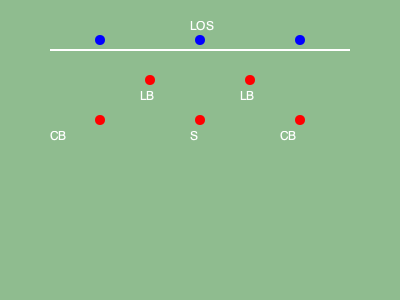Based on the defensive player positioning shown in the diagram, what type of coverage is being displayed? To identify the defensive coverage, let's analyze the positioning of the players step-by-step:

1. We can see 5 defensive players (red circles) lined up against 3 offensive players (blue circles).

2. There are two cornerbacks (CB) positioned on the outside, near the line of scrimmage (LOS).

3. Two linebackers (LB) are positioned slightly back from the LOS, forming a square-like shape with the CBs.

4. A single safety (S) is positioned deep in the middle of the field.

5. This formation with two CBs playing close to the LOS, two LBs in the middle, and a single high safety is characteristic of a Cover 3 zone defense.

6. In Cover 3, the two CBs and the deep safety are responsible for covering the deep thirds of the field, while the LBs cover the underneath zones.

7. This coverage allows for good run support from the LBs and CBs while still providing deep pass protection.

Given these observations, the defensive coverage being displayed is Cover 3.
Answer: Cover 3 